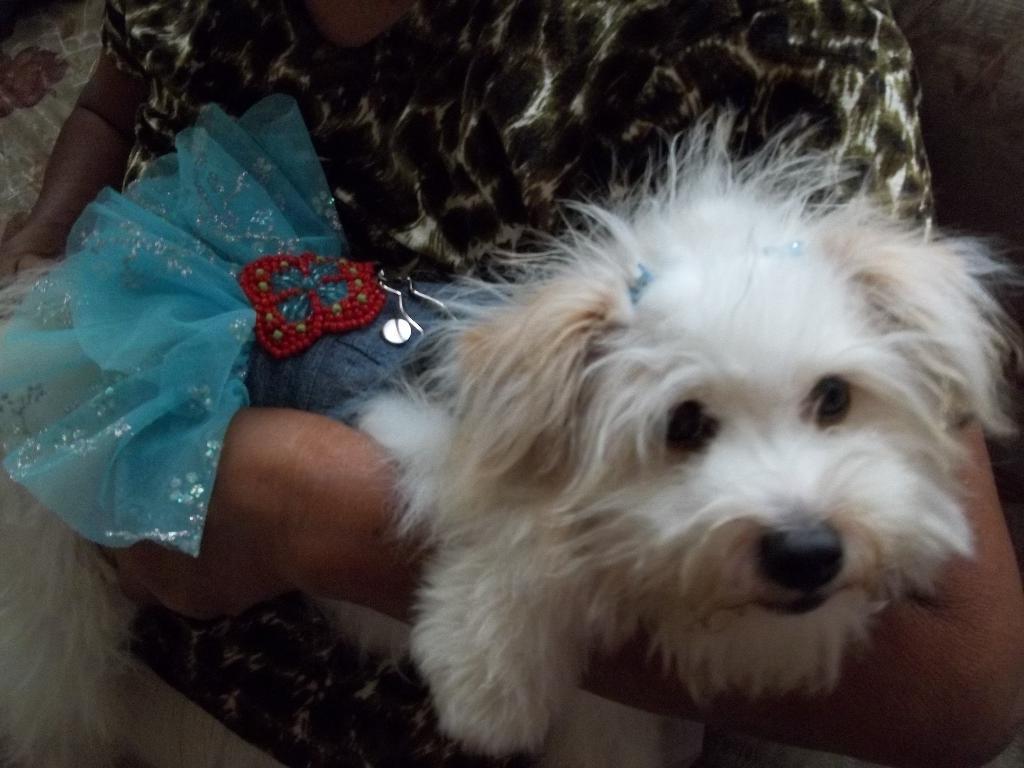Can you describe this image briefly? In the image I can see a dog to which there is a costume and also I can see a person hand. 